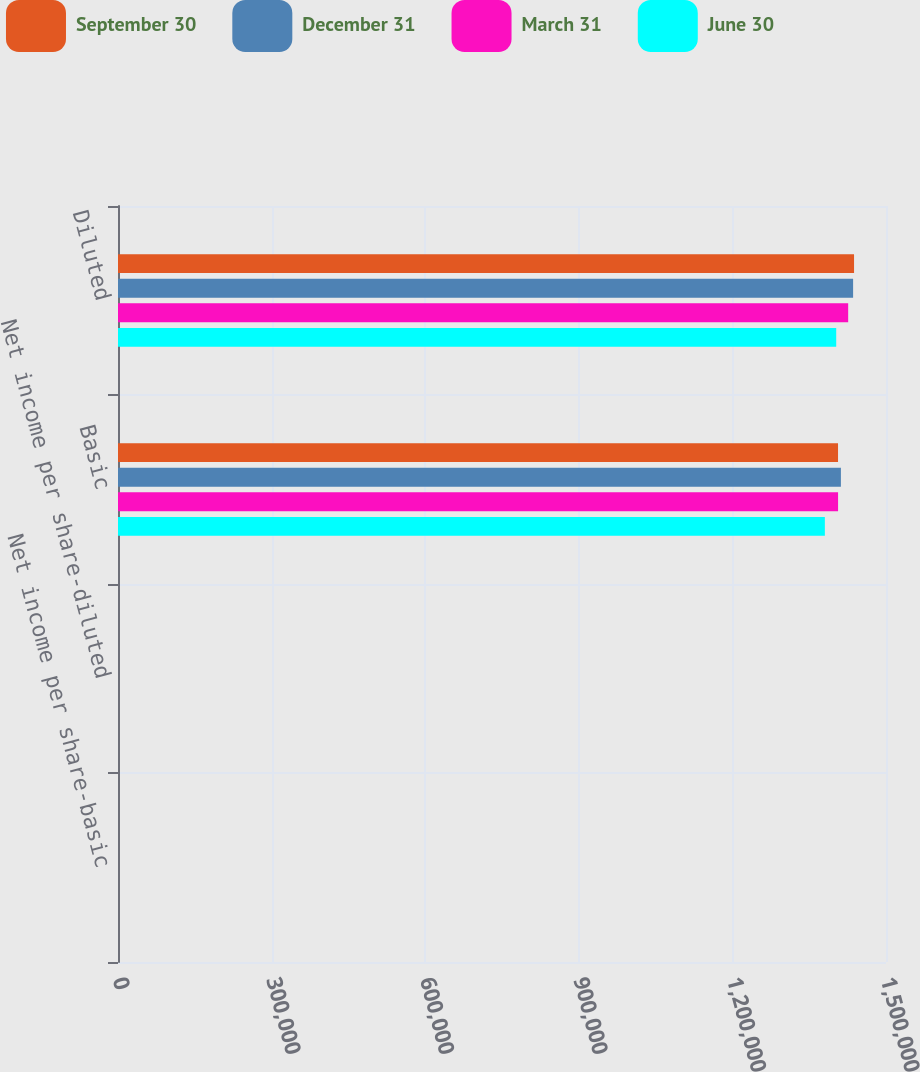<chart> <loc_0><loc_0><loc_500><loc_500><stacked_bar_chart><ecel><fcel>Net income per share-basic<fcel>Net income per share-diluted<fcel>Basic<fcel>Diluted<nl><fcel>September 30<fcel>0.18<fcel>0.17<fcel>1.40631e+06<fcel>1.43758e+06<nl><fcel>December 31<fcel>0.18<fcel>0.17<fcel>1.41192e+06<fcel>1.43576e+06<nl><fcel>March 31<fcel>0.2<fcel>0.2<fcel>1.40638e+06<fcel>1.42611e+06<nl><fcel>June 30<fcel>0.25<fcel>0.25<fcel>1.38058e+06<fcel>1.40275e+06<nl></chart> 